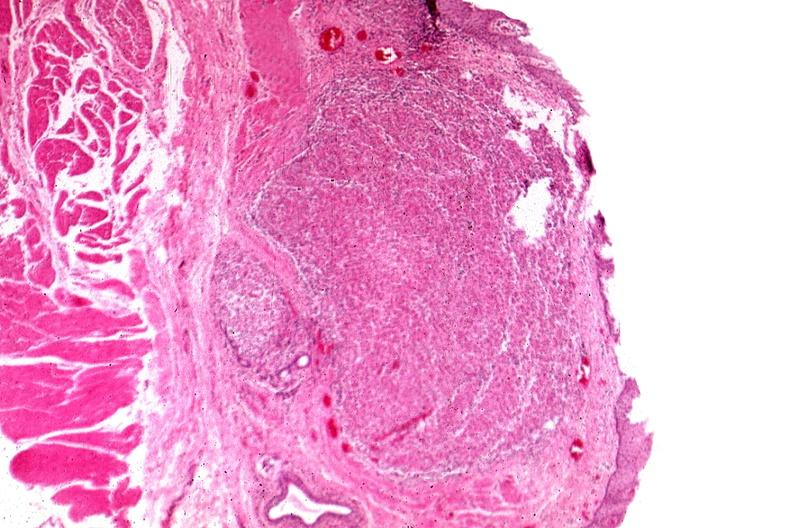does cortical nodule show tunica propria granulomas?
Answer the question using a single word or phrase. No 